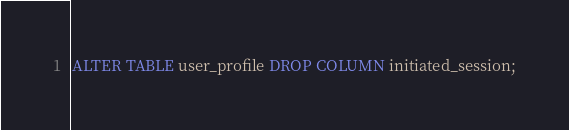<code> <loc_0><loc_0><loc_500><loc_500><_SQL_>ALTER TABLE user_profile DROP COLUMN initiated_session;
</code> 